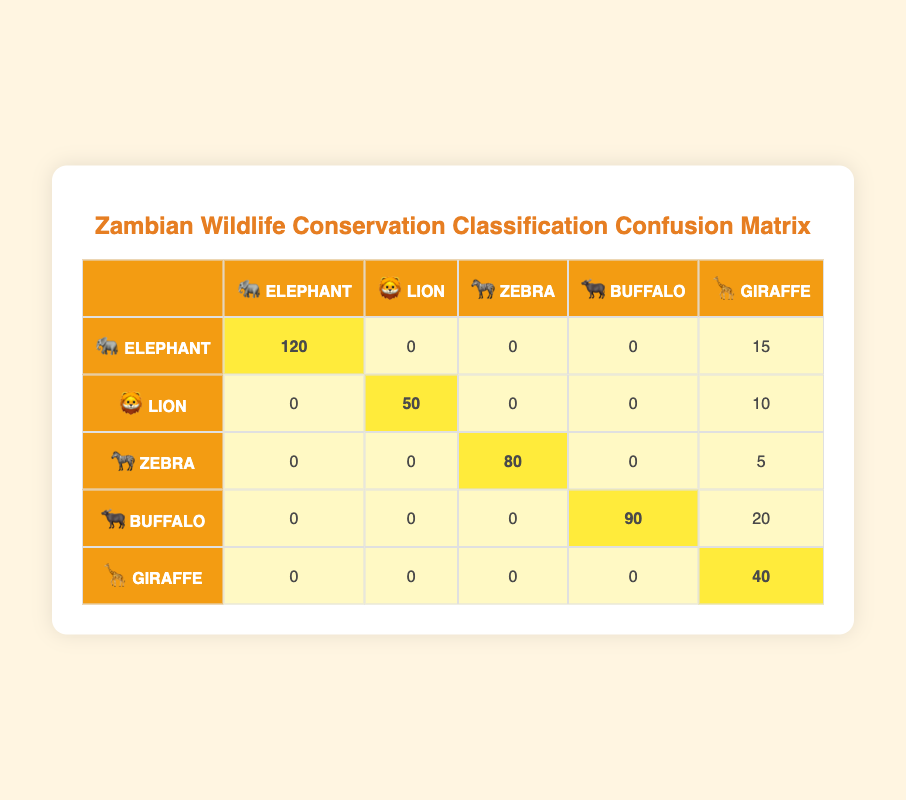What is the count of correctly identified Elephants? The table shows that the count of correctly identified Elephants is found on the diagonal under "Elephant" which is 120.
Answer: 120 How many Giraffes were incorrectly classified as Non-Giraffes? The table indicates that Giraffes were misclassified 8 times under "Non-Giraffe".
Answer: 8 What is the total number of Lions predicted in the classification? To find the total number of Lions predicted, we look at both correctly classified Lions (50) and those misclassified as Non-Lions (10). So the total is 50 + 10 = 60.
Answer: 60 Is the classification model more accurate for Elephants than for Zebras? The accuracy can be evaluated by looking at the correct classifications. Elephants were identified correctly 120 times while Zebras were correctly classified 80 times. Therefore, the model is indeed more accurate for Elephants.
Answer: Yes How many total misclassifications occurred for Buffalos? The total misclassifications for Buffalos can be found by adding those predicted as Non-Buffalo (20) to any Buffalo correctly classified (which is 90 under "Buffalo"). However, we're specifically looking for misclassifications which is just the 20. Therefore, the total misclassifications for Buffalos is 20.
Answer: 20 What is the average number of correct predictions across all species? We need to calculate the sum of correct predictions from all species: 120 (Elephant) + 50 (Lion) + 80 (Zebra) + 90 (Buffalo) + 40 (Giraffe) = 380. Then divide by the number of species which is 5. So, the average is 380/5 = 76.
Answer: 76 How many total animals were predicted in the classification? To find the total number, we need to sum all the counts: 120 + 15 + 50 + 10 + 80 + 5 + 90 + 20 + 40 + 8 = 428. Therefore, the total number of animals predicted in the classification is 428.
Answer: 428 Were any Non-Elephants actually predicted as Elephants? To answer this, we check the row for Elephants and see the count under "Non-Elephant" prediction which is 15. This means that 15 Non-Elephants were incorrectly predicted as Elephants.
Answer: Yes What is the total count of correctly identified wildlife species in the classification? The total count of correctly identified wildlife species is the sum of correctly classified counts which are: 120 (Elephant) + 50 (Lion) + 80 (Zebra) + 90 (Buffalo) + 40 (Giraffe) = 380.
Answer: 380 